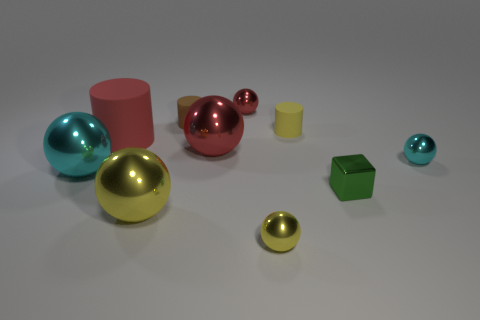What number of things are either large cylinders or metallic things on the right side of the brown thing?
Your answer should be compact. 6. Are there any tiny cubes of the same color as the big cylinder?
Keep it short and to the point. No. What number of blue things are either spheres or tiny balls?
Provide a short and direct response. 0. What number of other things are the same size as the green metal object?
Your response must be concise. 5. What number of big objects are cylinders or yellow cylinders?
Your response must be concise. 1. Does the brown thing have the same size as the ball that is to the right of the tiny yellow metal thing?
Your answer should be very brief. Yes. What number of other objects are there of the same shape as the big red metal thing?
Offer a very short reply. 5. What is the shape of the green object that is the same material as the small red sphere?
Keep it short and to the point. Cube. Are there any purple metallic balls?
Make the answer very short. No. Are there fewer yellow spheres on the left side of the brown cylinder than green blocks that are on the left side of the red rubber object?
Provide a short and direct response. No. 